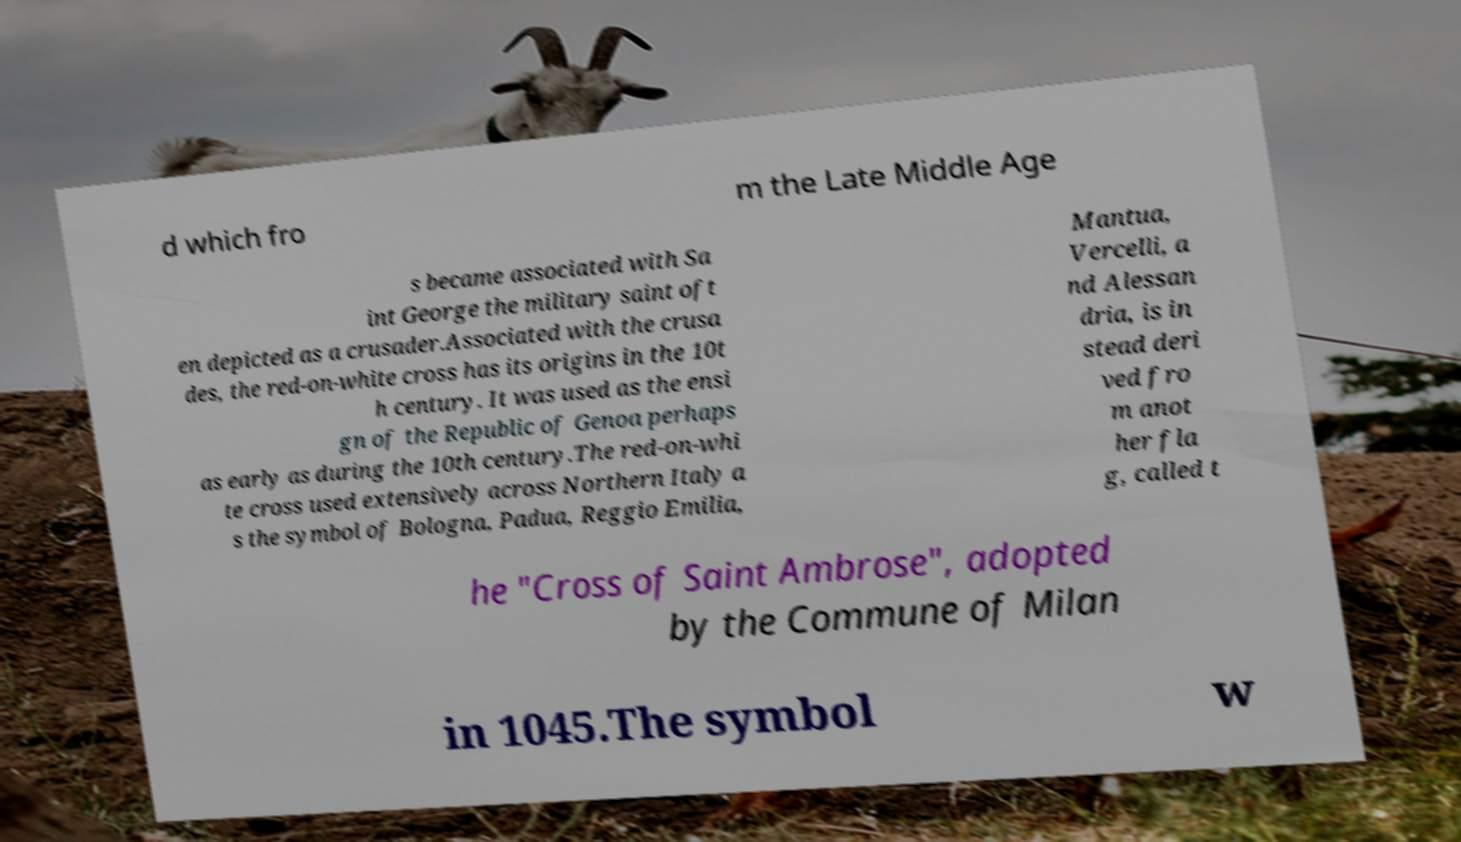Can you read and provide the text displayed in the image?This photo seems to have some interesting text. Can you extract and type it out for me? d which fro m the Late Middle Age s became associated with Sa int George the military saint oft en depicted as a crusader.Associated with the crusa des, the red-on-white cross has its origins in the 10t h century. It was used as the ensi gn of the Republic of Genoa perhaps as early as during the 10th century.The red-on-whi te cross used extensively across Northern Italy a s the symbol of Bologna, Padua, Reggio Emilia, Mantua, Vercelli, a nd Alessan dria, is in stead deri ved fro m anot her fla g, called t he "Cross of Saint Ambrose", adopted by the Commune of Milan in 1045.The symbol w 